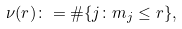<formula> <loc_0><loc_0><loc_500><loc_500>\nu ( r ) \colon = \# \{ j \colon m _ { j } \leq r \} ,</formula> 